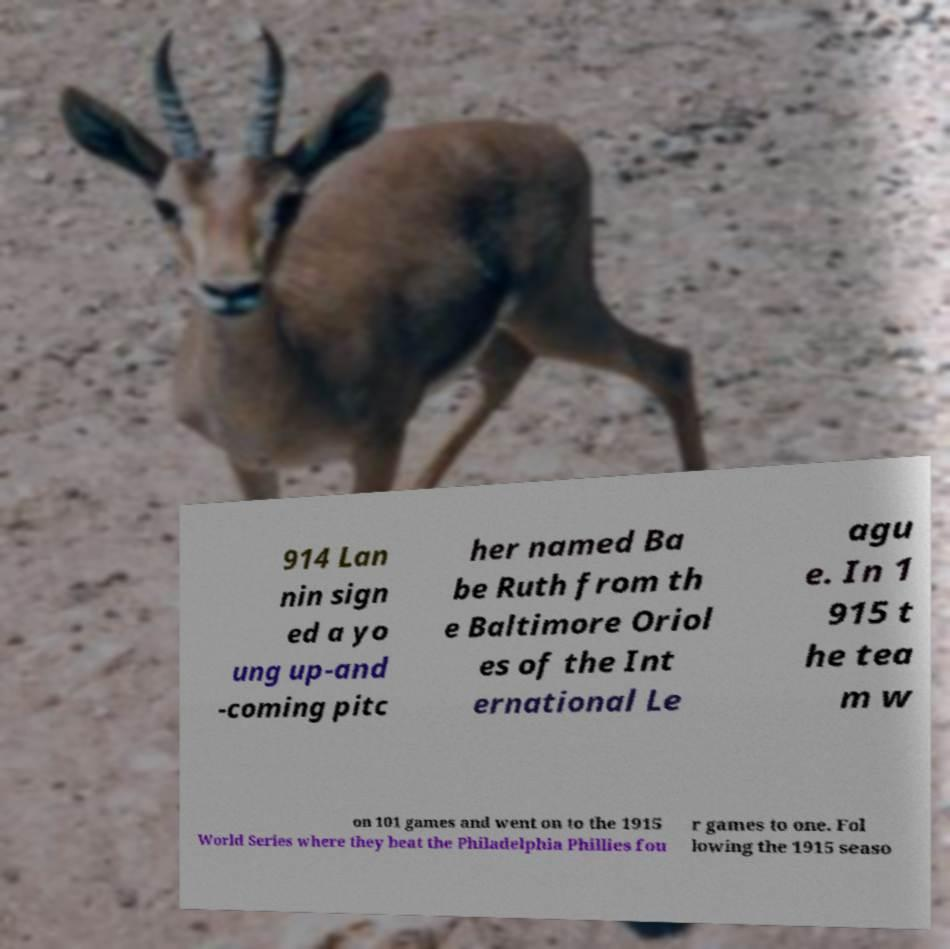Please identify and transcribe the text found in this image. 914 Lan nin sign ed a yo ung up-and -coming pitc her named Ba be Ruth from th e Baltimore Oriol es of the Int ernational Le agu e. In 1 915 t he tea m w on 101 games and went on to the 1915 World Series where they beat the Philadelphia Phillies fou r games to one. Fol lowing the 1915 seaso 